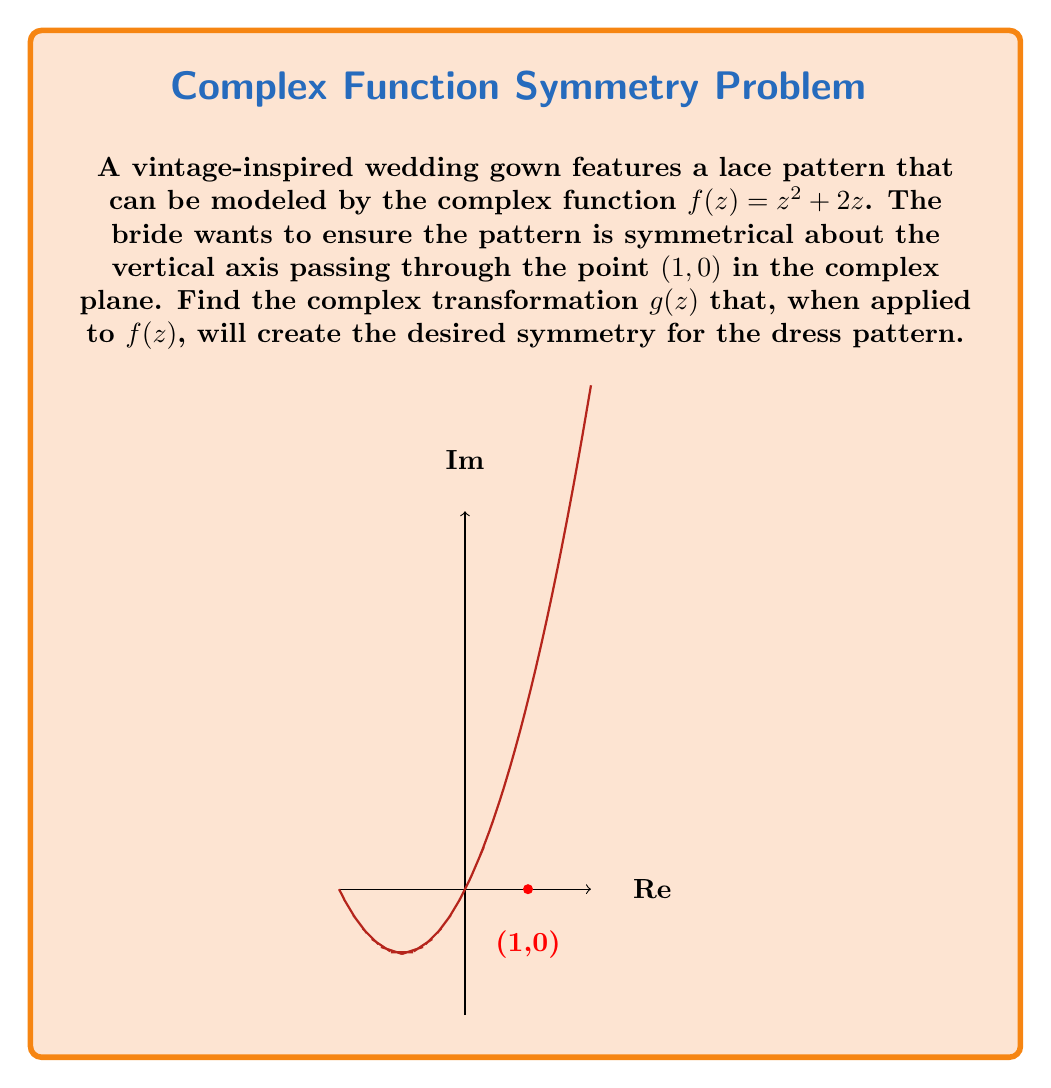Teach me how to tackle this problem. To create symmetry about the vertical axis passing through $(1, 0)$, we need to follow these steps:

1) First, we need to shift the function so that the axis of symmetry is at the origin. This is done by subtracting 1 from z:

   $h(z) = f(z - 1) = (z-1)^2 + 2(z-1)$

2) Now, to create symmetry about the vertical axis, we need to apply the complex conjugate. The complex conjugate of $z$ is denoted as $\overline{z}$:

   $j(z) = \overline{h(\overline{z})}$

3) Finally, we need to shift the function back by adding 1 to z:

   $g(z) = j(z+1) = \overline{h(\overline{z+1})}$

4) Expanding this:

   $g(z) = \overline{(\overline{z+1}-1)^2 + 2(\overline{z+1}-1)}$
   
   $= \overline{(\overline{z})^2 + 2(\overline{z})}$
   
   $= z^2 + 2z$

5) Therefore, the complex transformation $g(z)$ that creates the desired symmetry is:

   $g(z) = \overline{f(\overline{z+1})-1}$

This transformation first shifts the function, then applies the complex conjugate, and finally shifts it back, creating symmetry about the vertical axis passing through $(1, 0)$.
Answer: $g(z) = \overline{f(\overline{z+1})-1}$ 